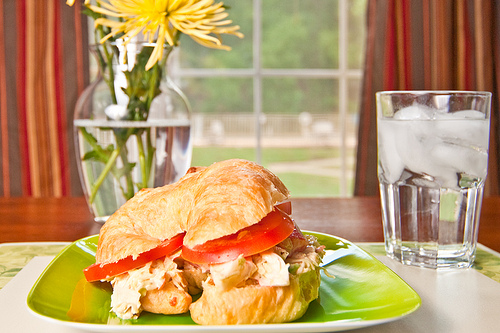Are there any green plates or cakes? Yes, there is a green plate in the image. 